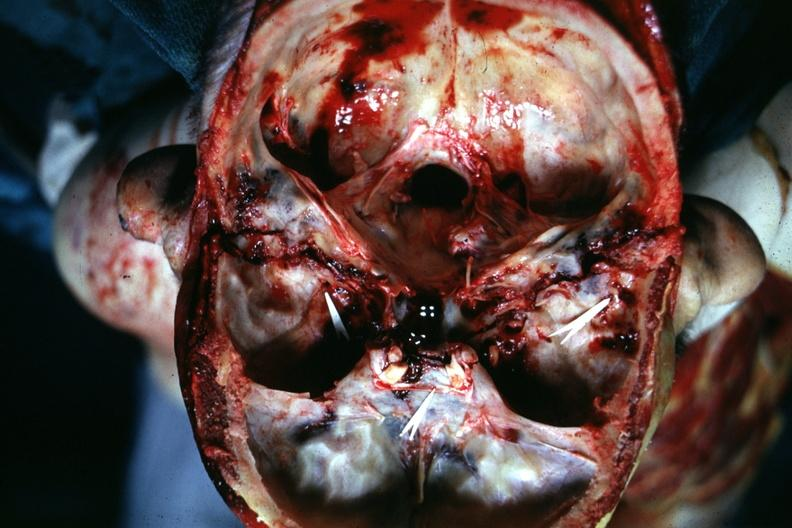what is present?
Answer the question using a single word or phrase. Bone, calvarium 